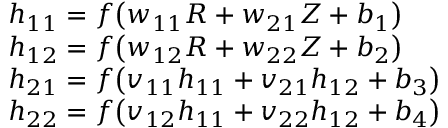Convert formula to latex. <formula><loc_0><loc_0><loc_500><loc_500>\begin{array} { r l } & { h _ { 1 1 } = f \left ( w _ { 1 1 } R + w _ { 2 1 } Z + b _ { 1 } \right ) } \\ & { h _ { 1 2 } = f \left ( w _ { 1 2 } R + w _ { 2 2 } Z + b _ { 2 } \right ) } \\ & { h _ { 2 1 } = f \left ( v _ { 1 1 } h _ { 1 1 } + v _ { 2 1 } h _ { 1 2 } + b _ { 3 } \right ) } \\ & { h _ { 2 2 } = f \left ( v _ { 1 2 } h _ { 1 1 } + v _ { 2 2 } h _ { 1 2 } + b _ { 4 } \right ) } \end{array}</formula> 